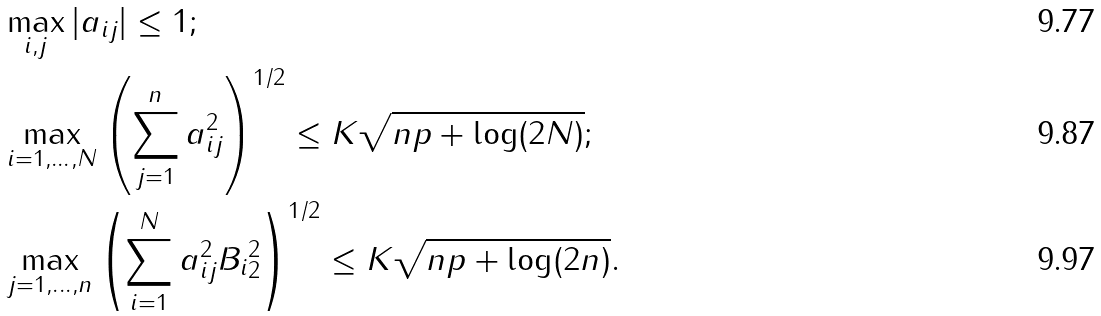Convert formula to latex. <formula><loc_0><loc_0><loc_500><loc_500>& \max _ { i , j } | a _ { i j } | \leq 1 ; \\ & \max _ { i = 1 , \dots , N } \left ( \sum _ { j = 1 } ^ { n } a _ { i j } ^ { 2 } \right ) ^ { 1 / 2 } \leq K \sqrt { n p + \log ( 2 N ) } ; \\ & \max _ { j = 1 , \dots , n } \left ( \sum _ { i = 1 } ^ { N } a _ { i j } ^ { 2 } \| B _ { i } \| _ { 2 } ^ { 2 } \right ) ^ { 1 / 2 } \leq K \sqrt { n p + \log ( 2 n ) } .</formula> 